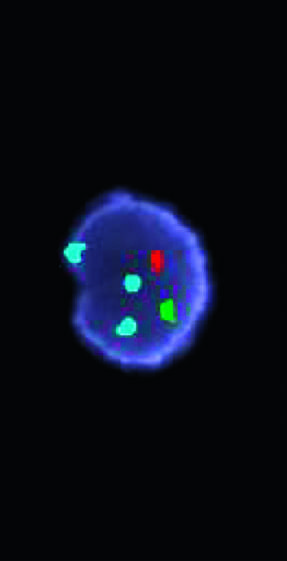how many copies does the red probe hybridize to the y chromosome centromere?
Answer the question using a single word or phrase. One 